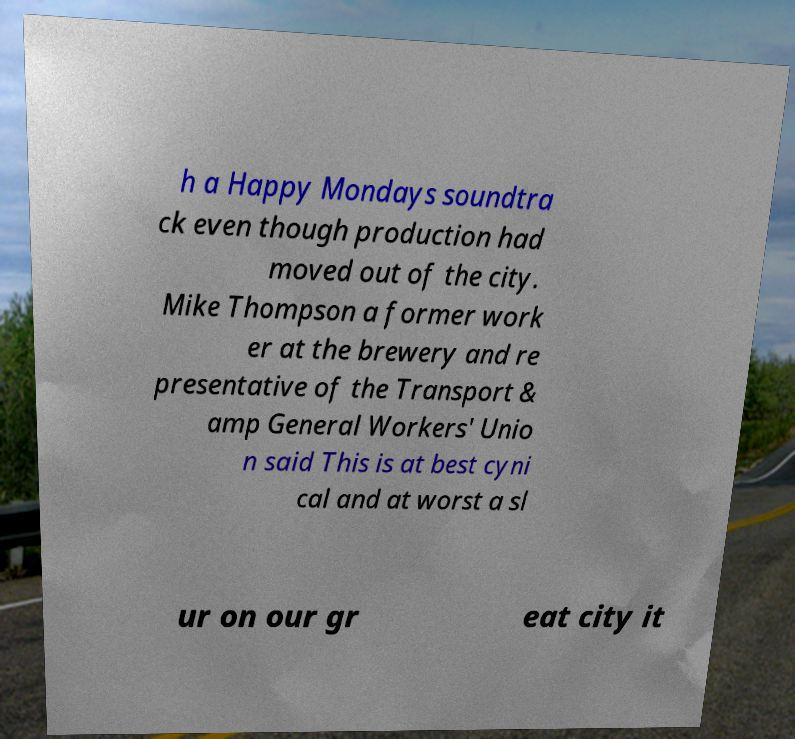Can you read and provide the text displayed in the image?This photo seems to have some interesting text. Can you extract and type it out for me? h a Happy Mondays soundtra ck even though production had moved out of the city. Mike Thompson a former work er at the brewery and re presentative of the Transport & amp General Workers' Unio n said This is at best cyni cal and at worst a sl ur on our gr eat city it 